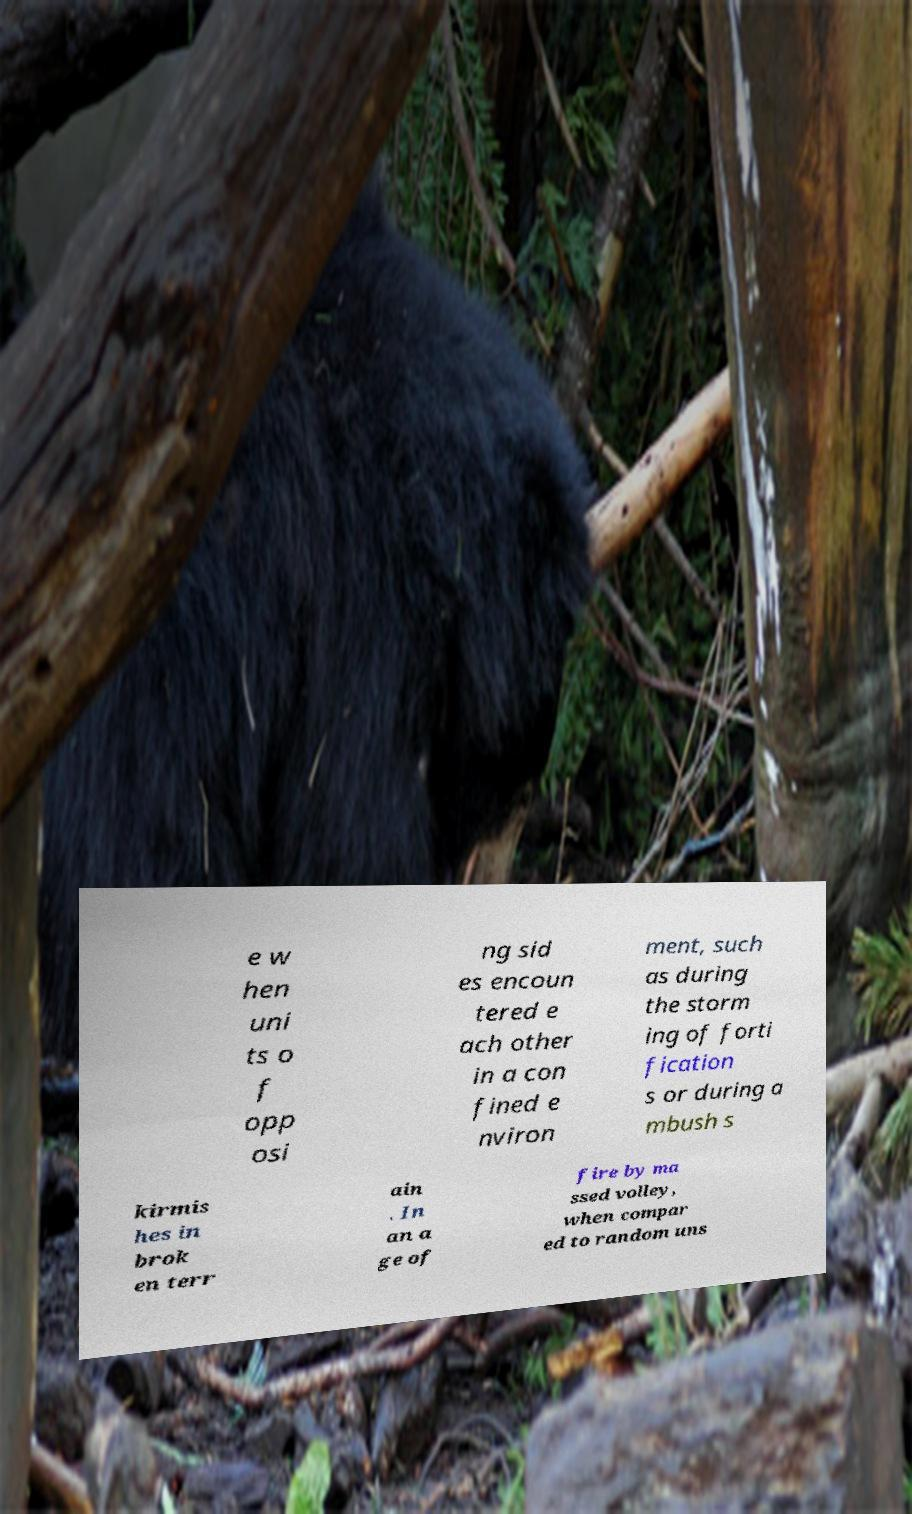I need the written content from this picture converted into text. Can you do that? e w hen uni ts o f opp osi ng sid es encoun tered e ach other in a con fined e nviron ment, such as during the storm ing of forti fication s or during a mbush s kirmis hes in brok en terr ain . In an a ge of fire by ma ssed volley, when compar ed to random uns 